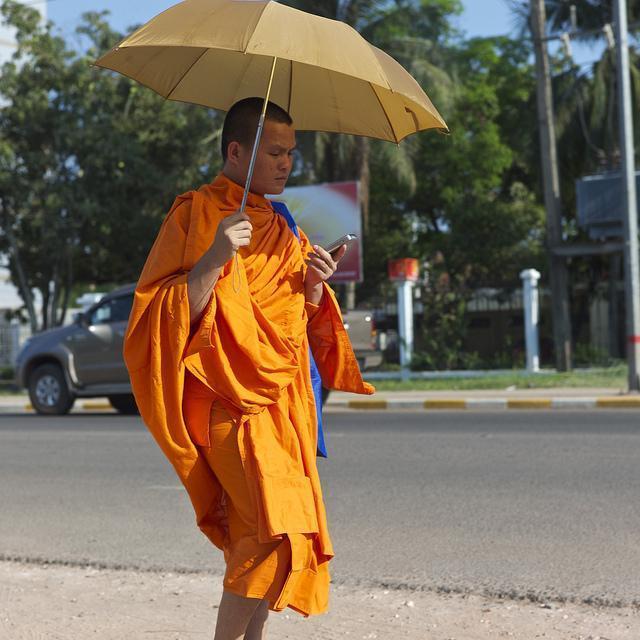Does the image validate the caption "The person is inside the truck."?
Answer yes or no. No. Does the image validate the caption "The truck is touching the person."?
Answer yes or no. No. 